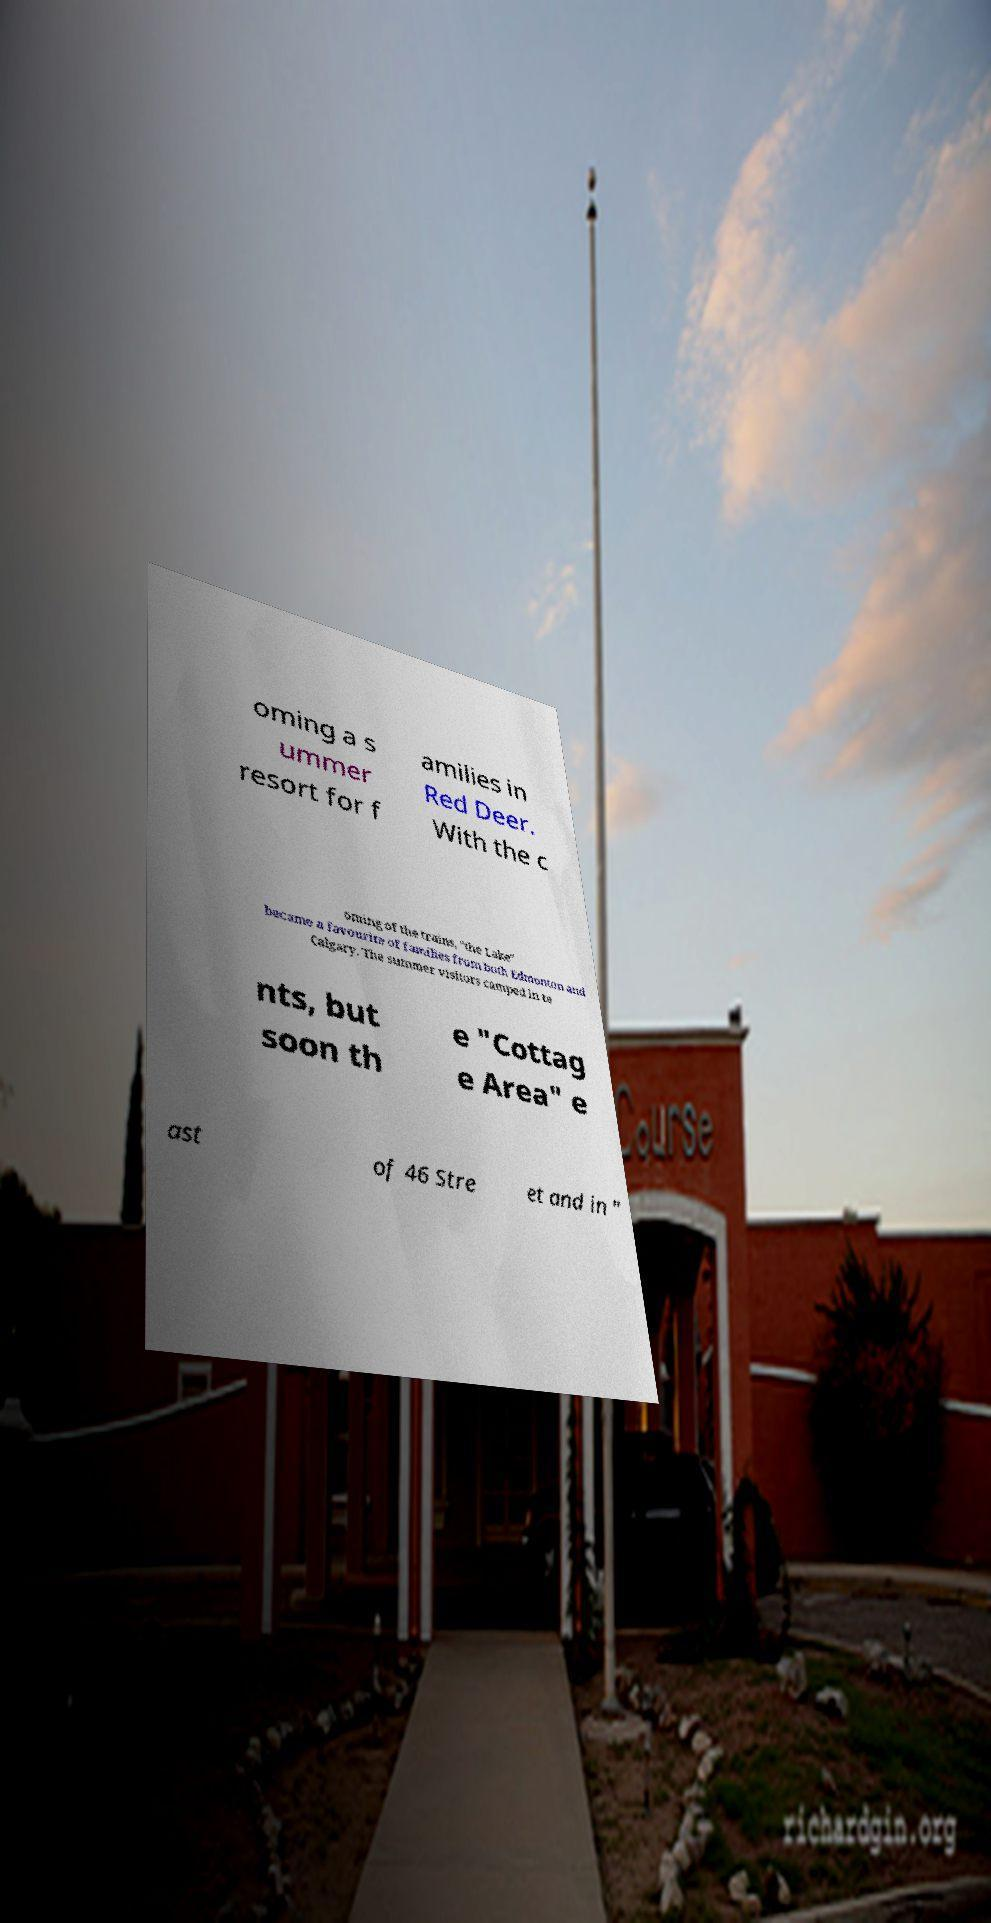Can you accurately transcribe the text from the provided image for me? oming a s ummer resort for f amilies in Red Deer. With the c oming of the trains, "the Lake" became a favourite of families from both Edmonton and Calgary. The summer visitors camped in te nts, but soon th e "Cottag e Area" e ast of 46 Stre et and in " 